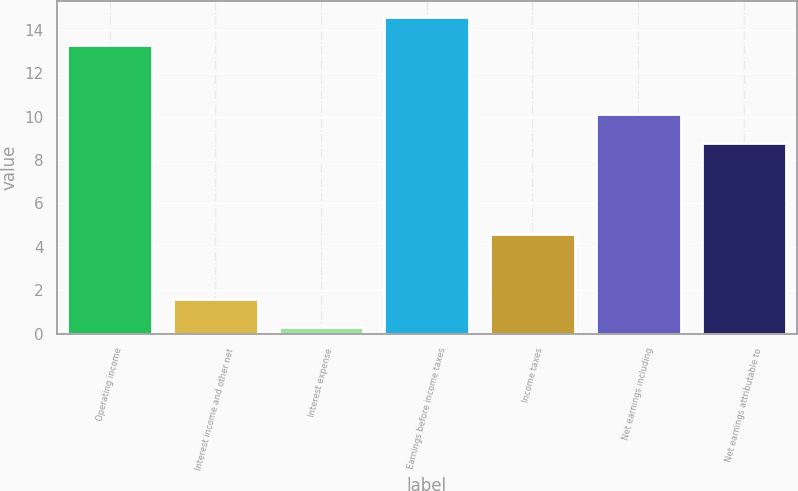Convert chart to OTSL. <chart><loc_0><loc_0><loc_500><loc_500><bar_chart><fcel>Operating income<fcel>Interest income and other net<fcel>Interest expense<fcel>Earnings before income taxes<fcel>Income taxes<fcel>Net earnings including<fcel>Net earnings attributable to<nl><fcel>13.3<fcel>1.61<fcel>0.3<fcel>14.61<fcel>4.6<fcel>10.11<fcel>8.8<nl></chart> 